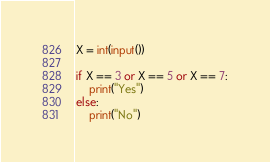Convert code to text. <code><loc_0><loc_0><loc_500><loc_500><_Python_>X = int(input())

if X == 3 or X == 5 or X == 7:
    print("Yes")
else:
    print("No")</code> 